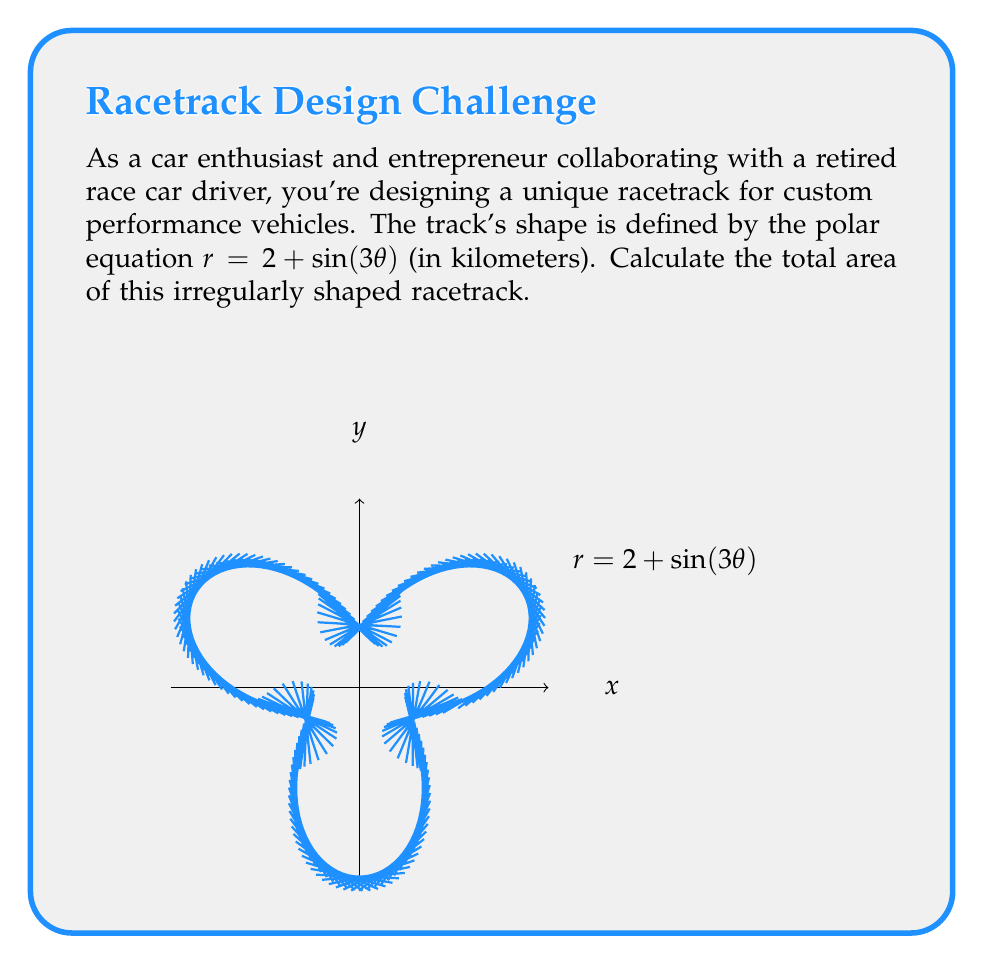What is the answer to this math problem? To find the area of this irregularly shaped racetrack, we'll use polar integration. The formula for the area of a region in polar coordinates is:

$$A = \frac{1}{2} \int_{0}^{2\pi} r^2(\theta) d\theta$$

Let's solve this step-by-step:

1) Our polar equation is $r = 2 + \sin(3\theta)$. We need to square this:

   $r^2 = (2 + \sin(3\theta))^2 = 4 + 4\sin(3\theta) + \sin^2(3\theta)$

2) Now, we set up our integral:

   $$A = \frac{1}{2} \int_{0}^{2\pi} (4 + 4\sin(3\theta) + \sin^2(3\theta)) d\theta$$

3) Let's integrate each term separately:
   
   a) $\int_{0}^{2\pi} 4 d\theta = 4\theta \big|_{0}^{2\pi} = 8\pi$
   
   b) $\int_{0}^{2\pi} 4\sin(3\theta) d\theta = -\frac{4}{3}\cos(3\theta) \big|_{0}^{2\pi} = 0$
   
   c) For $\int_{0}^{2\pi} \sin^2(3\theta) d\theta$, we use the identity $\sin^2 x = \frac{1}{2}(1-\cos(2x))$:
      
      $\int_{0}^{2\pi} \sin^2(3\theta) d\theta = \int_{0}^{2\pi} \frac{1}{2}(1-\cos(6\theta)) d\theta$
      
      $= \frac{1}{2}\theta - \frac{1}{12}\sin(6\theta) \big|_{0}^{2\pi} = \pi$

4) Adding these results:

   $$A = \frac{1}{2}(8\pi + 0 + \pi) = \frac{9\pi}{2}$$

5) Therefore, the area of the racetrack is $\frac{9\pi}{2}$ square kilometers.
Answer: $\frac{9\pi}{2}$ km² 